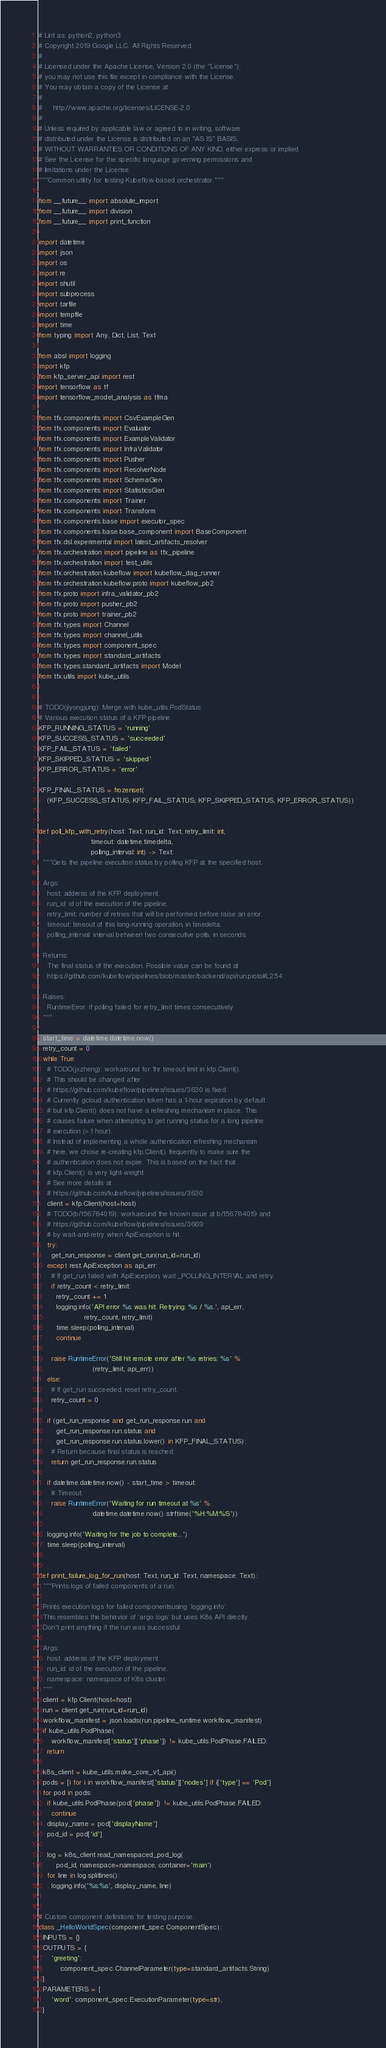<code> <loc_0><loc_0><loc_500><loc_500><_Python_># Lint as: python2, python3
# Copyright 2019 Google LLC. All Rights Reserved.
#
# Licensed under the Apache License, Version 2.0 (the "License");
# you may not use this file except in compliance with the License.
# You may obtain a copy of the License at
#
#     http://www.apache.org/licenses/LICENSE-2.0
#
# Unless required by applicable law or agreed to in writing, software
# distributed under the License is distributed on an "AS IS" BASIS,
# WITHOUT WARRANTIES OR CONDITIONS OF ANY KIND, either express or implied.
# See the License for the specific language governing permissions and
# limitations under the License.
"""Common utility for testing Kubeflow-based orchestrator."""

from __future__ import absolute_import
from __future__ import division
from __future__ import print_function

import datetime
import json
import os
import re
import shutil
import subprocess
import tarfile
import tempfile
import time
from typing import Any, Dict, List, Text

from absl import logging
import kfp
from kfp_server_api import rest
import tensorflow as tf
import tensorflow_model_analysis as tfma

from tfx.components import CsvExampleGen
from tfx.components import Evaluator
from tfx.components import ExampleValidator
from tfx.components import InfraValidator
from tfx.components import Pusher
from tfx.components import ResolverNode
from tfx.components import SchemaGen
from tfx.components import StatisticsGen
from tfx.components import Trainer
from tfx.components import Transform
from tfx.components.base import executor_spec
from tfx.components.base.base_component import BaseComponent
from tfx.dsl.experimental import latest_artifacts_resolver
from tfx.orchestration import pipeline as tfx_pipeline
from tfx.orchestration import test_utils
from tfx.orchestration.kubeflow import kubeflow_dag_runner
from tfx.orchestration.kubeflow.proto import kubeflow_pb2
from tfx.proto import infra_validator_pb2
from tfx.proto import pusher_pb2
from tfx.proto import trainer_pb2
from tfx.types import Channel
from tfx.types import channel_utils
from tfx.types import component_spec
from tfx.types import standard_artifacts
from tfx.types.standard_artifacts import Model
from tfx.utils import kube_utils


# TODO(jiyongjung): Merge with kube_utils.PodStatus
# Various execution status of a KFP pipeline.
KFP_RUNNING_STATUS = 'running'
KFP_SUCCESS_STATUS = 'succeeded'
KFP_FAIL_STATUS = 'failed'
KFP_SKIPPED_STATUS = 'skipped'
KFP_ERROR_STATUS = 'error'

KFP_FINAL_STATUS = frozenset(
    (KFP_SUCCESS_STATUS, KFP_FAIL_STATUS, KFP_SKIPPED_STATUS, KFP_ERROR_STATUS))


def poll_kfp_with_retry(host: Text, run_id: Text, retry_limit: int,
                        timeout: datetime.timedelta,
                        polling_interval: int) -> Text:
  """Gets the pipeline execution status by polling KFP at the specified host.

  Args:
    host: address of the KFP deployment.
    run_id: id of the execution of the pipeline.
    retry_limit: number of retries that will be performed before raise an error.
    timeout: timeout of this long-running operation, in timedelta.
    polling_interval: interval between two consecutive polls, in seconds.

  Returns:
    The final status of the execution. Possible value can be found at
    https://github.com/kubeflow/pipelines/blob/master/backend/api/run.proto#L254

  Raises:
    RuntimeError: if polling failed for retry_limit times consecutively.
  """

  start_time = datetime.datetime.now()
  retry_count = 0
  while True:
    # TODO(jxzheng): workaround for 1hr timeout limit in kfp.Client().
    # This should be changed after
    # https://github.com/kubeflow/pipelines/issues/3630 is fixed.
    # Currently gcloud authentication token has a 1-hour expiration by default
    # but kfp.Client() does not have a refreshing mechanism in place. This
    # causes failure when attempting to get running status for a long pipeline
    # execution (> 1 hour).
    # Instead of implementing a whole authentication refreshing mechanism
    # here, we chose re-creating kfp.Client() frequently to make sure the
    # authentication does not expire. This is based on the fact that
    # kfp.Client() is very light-weight.
    # See more details at
    # https://github.com/kubeflow/pipelines/issues/3630
    client = kfp.Client(host=host)
    # TODO(b/156784019): workaround the known issue at b/156784019 and
    # https://github.com/kubeflow/pipelines/issues/3669
    # by wait-and-retry when ApiException is hit.
    try:
      get_run_response = client.get_run(run_id=run_id)
    except rest.ApiException as api_err:
      # If get_run failed with ApiException, wait _POLLING_INTERVAL and retry.
      if retry_count < retry_limit:
        retry_count += 1
        logging.info('API error %s was hit. Retrying: %s / %s.', api_err,
                     retry_count, retry_limit)
        time.sleep(polling_interval)
        continue

      raise RuntimeError('Still hit remote error after %s retries: %s' %
                         (retry_limit, api_err))
    else:
      # If get_run succeeded, reset retry_count.
      retry_count = 0

    if (get_run_response and get_run_response.run and
        get_run_response.run.status and
        get_run_response.run.status.lower() in KFP_FINAL_STATUS):
      # Return because final status is reached.
      return get_run_response.run.status

    if datetime.datetime.now() - start_time > timeout:
      # Timeout.
      raise RuntimeError('Waiting for run timeout at %s' %
                         datetime.datetime.now().strftime('%H:%M:%S'))

    logging.info('Waiting for the job to complete...')
    time.sleep(polling_interval)


def print_failure_log_for_run(host: Text, run_id: Text, namespace: Text):
  """Prints logs of failed components of a run.

  Prints execution logs for failed componentsusing `logging.info`.
  This resembles the behavior of `argo logs` but uses K8s API directly.
  Don't print anything if the run was successful.

  Args:
    host: address of the KFP deployment.
    run_id: id of the execution of the pipeline.
    namespace: namespace of K8s cluster.
  """
  client = kfp.Client(host=host)
  run = client.get_run(run_id=run_id)
  workflow_manifest = json.loads(run.pipeline_runtime.workflow_manifest)
  if kube_utils.PodPhase(
      workflow_manifest['status']['phase']) != kube_utils.PodPhase.FAILED:
    return

  k8s_client = kube_utils.make_core_v1_api()
  pods = [i for i in workflow_manifest['status']['nodes'] if i['type'] == 'Pod']
  for pod in pods:
    if kube_utils.PodPhase(pod['phase']) != kube_utils.PodPhase.FAILED:
      continue
    display_name = pod['displayName']
    pod_id = pod['id']

    log = k8s_client.read_namespaced_pod_log(
        pod_id, namespace=namespace, container='main')
    for line in log.splitlines():
      logging.info('%s:%s', display_name, line)


# Custom component definitions for testing purpose.
class _HelloWorldSpec(component_spec.ComponentSpec):
  INPUTS = {}
  OUTPUTS = {
      'greeting':
          component_spec.ChannelParameter(type=standard_artifacts.String)
  }
  PARAMETERS = {
      'word': component_spec.ExecutionParameter(type=str),
  }

</code> 